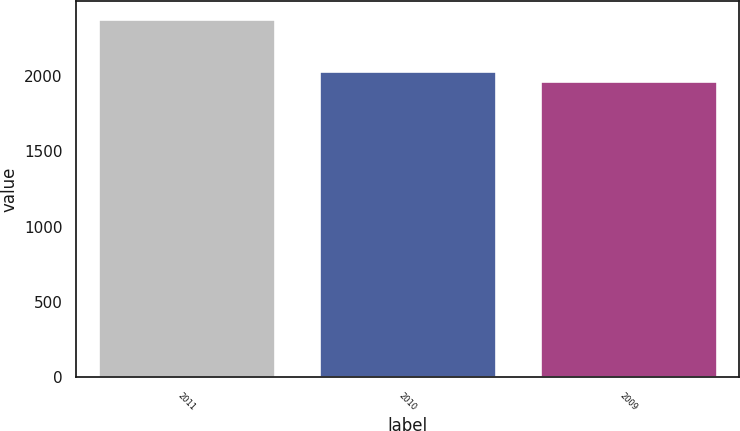Convert chart to OTSL. <chart><loc_0><loc_0><loc_500><loc_500><bar_chart><fcel>2011<fcel>2010<fcel>2009<nl><fcel>2377<fcel>2035<fcel>1965<nl></chart> 